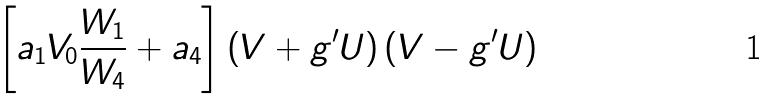<formula> <loc_0><loc_0><loc_500><loc_500>\left [ a _ { 1 } V _ { 0 } \frac { W _ { 1 } } { W _ { 4 } } + a _ { 4 } \right ] \left ( V + g ^ { \prime } U \right ) \left ( V - g ^ { \prime } U \right )</formula> 